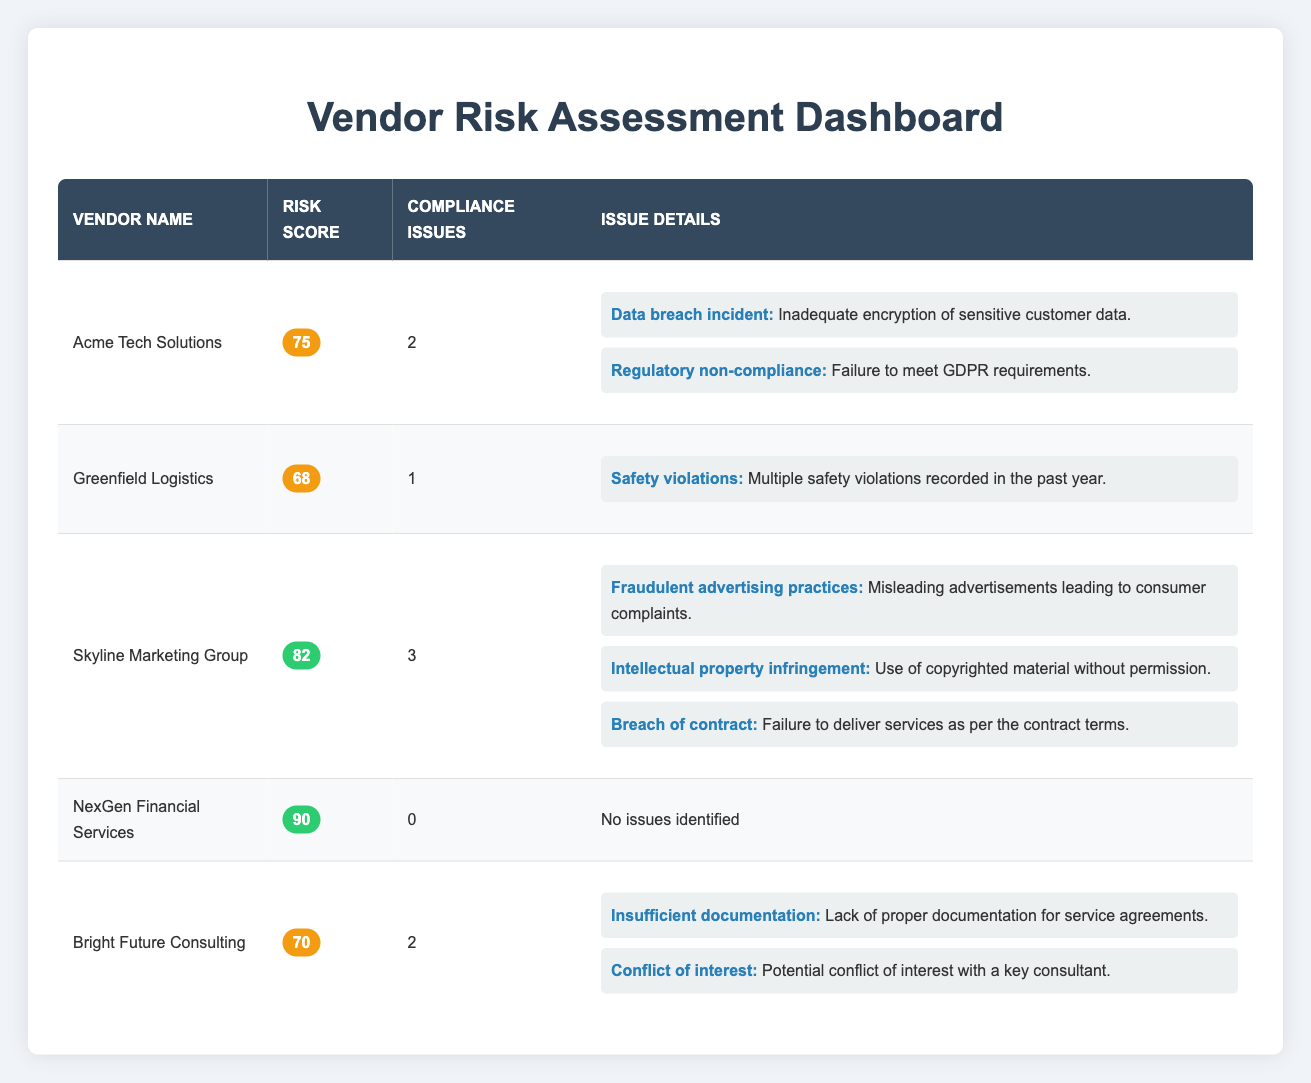What is the risk score of Acme Tech Solutions? The table shows that Acme Tech Solutions has a risk score of 75 listed in the "Risk Score" column next to the vendor name.
Answer: 75 Which vendor has the highest risk score? By comparing the risk scores of all vendors, NexGen Financial Services has the highest risk score of 90.
Answer: NexGen Financial Services How many compliance issues does Skyline Marketing Group have? The "Compliance Issues" column indicates that Skyline Marketing Group has 3 compliance issues listed.
Answer: 3 Did any vendors have compliance issues identified? Looking at the "Compliance Issues" column, all vendors except NexGen Financial Services have identified compliance issues. Therefore, yes, some vendors had compliance issues.
Answer: Yes What is the total number of compliance issues identified across all vendors? Adding the compliance issues across the rows: 2 (Acme) + 1 (Greenfield) + 3 (Skyline) + 0 (NexGen) + 2 (Bright Future) gives a total of 8 compliance issues.
Answer: 8 Which vendor has a compliance issue related to safety violations and what is the description? The table shows Greenfield Logistics has a compliance issue categorized as "Safety violations," described as "Multiple safety violations recorded in the past year."
Answer: Greenfield Logistics - Multiple safety violations recorded in the past year What is the average risk score of the vendors listed? The total risk scores are 75 (Acme) + 68 (Greenfield) + 82 (Skyline) + 90 (NexGen) + 70 (Bright Future) = 385. Since there are 5 vendors, the average is 385/5 = 77.
Answer: 77 Which vendor has the most types of compliance issues identified and what are those issues? Upon review, Skyline Marketing Group has the most types of compliance issues with 3 identified issues: Fraudulent advertising practices, Intellectual property infringement, and Breach of contract.
Answer: Skyline Marketing Group - Fraudulent advertising practices, Intellectual property infringement, Breach of contract 